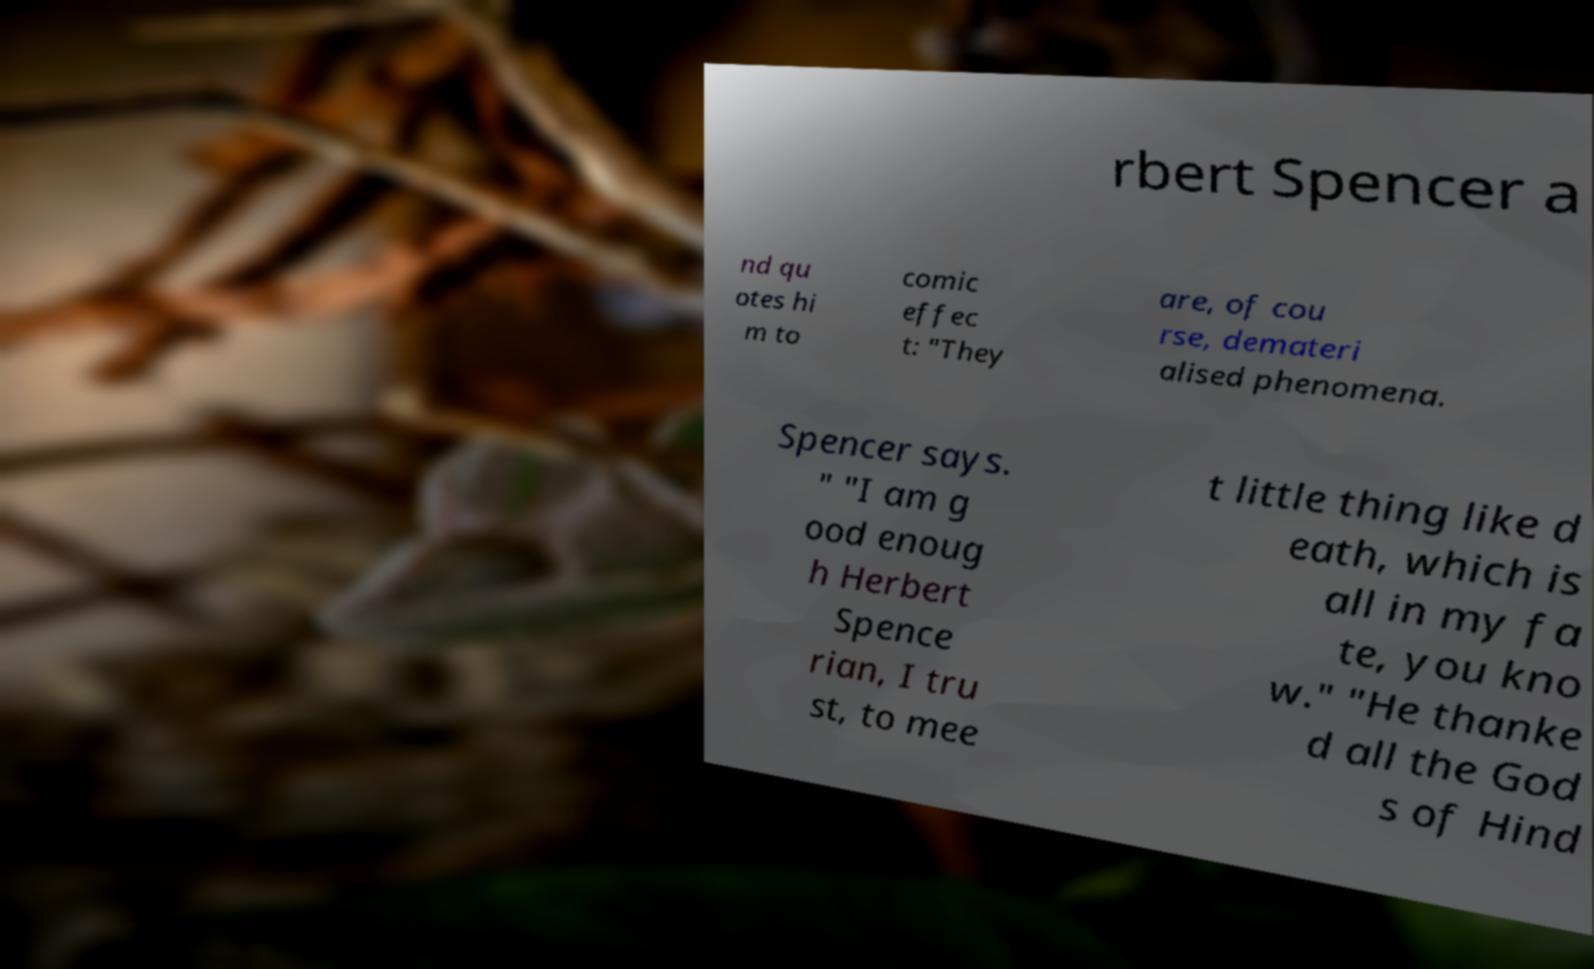I need the written content from this picture converted into text. Can you do that? rbert Spencer a nd qu otes hi m to comic effec t: "They are, of cou rse, demateri alised phenomena. Spencer says. " "I am g ood enoug h Herbert Spence rian, I tru st, to mee t little thing like d eath, which is all in my fa te, you kno w." "He thanke d all the God s of Hind 